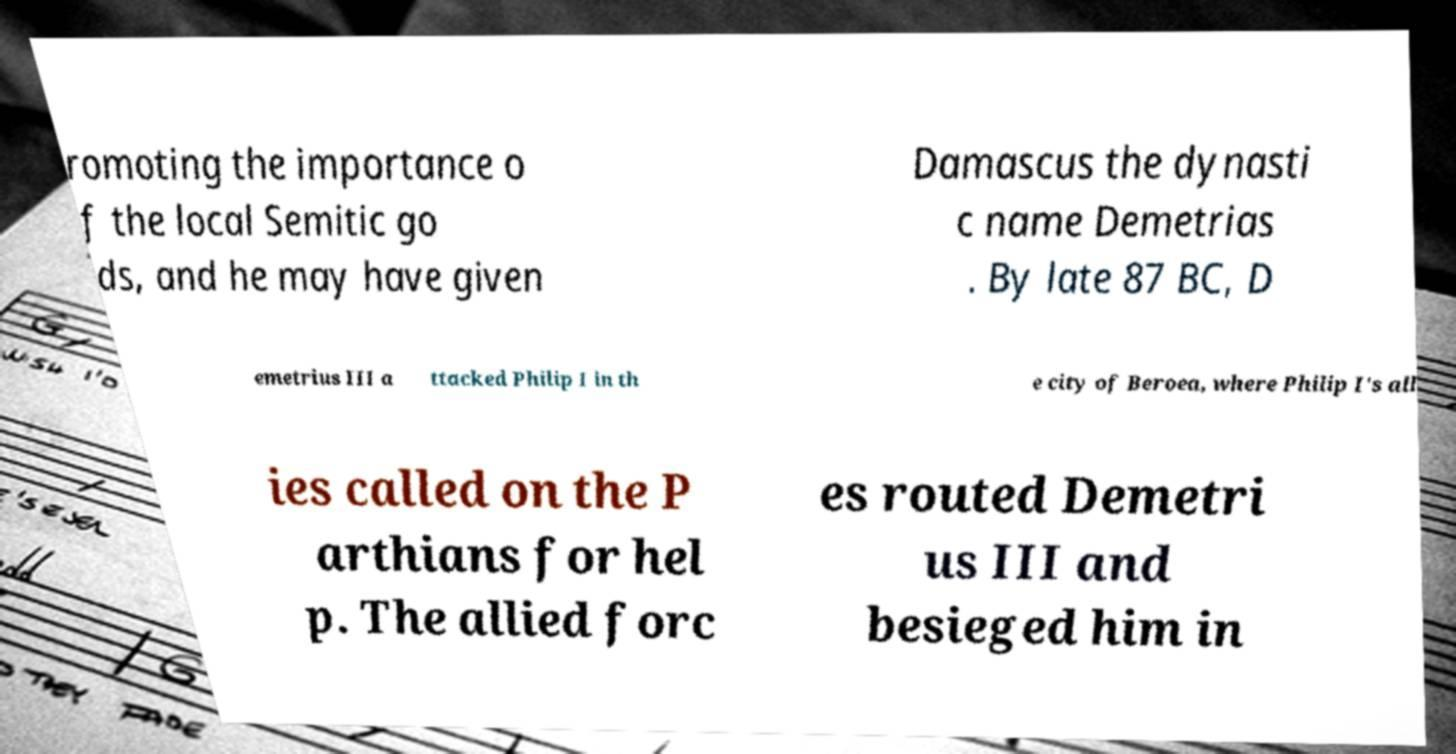Can you accurately transcribe the text from the provided image for me? romoting the importance o f the local Semitic go ds, and he may have given Damascus the dynasti c name Demetrias . By late 87 BC, D emetrius III a ttacked Philip I in th e city of Beroea, where Philip I's all ies called on the P arthians for hel p. The allied forc es routed Demetri us III and besieged him in 